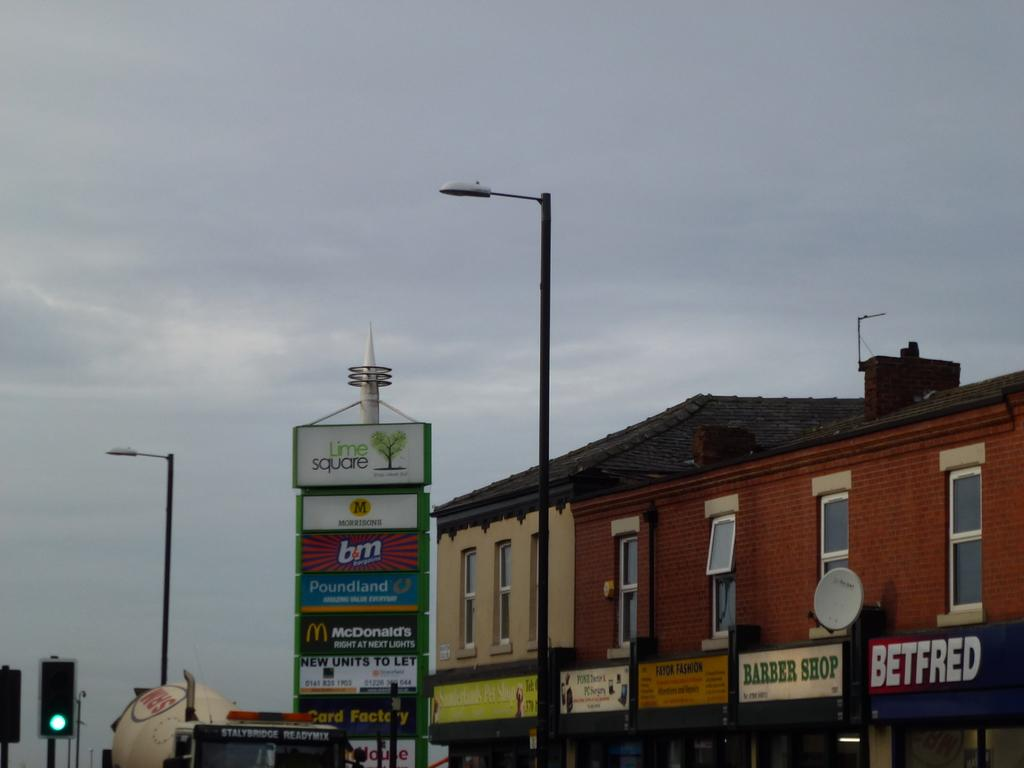<image>
Create a compact narrative representing the image presented. Lime Square has a variety of businesses available. 